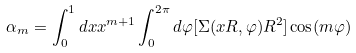<formula> <loc_0><loc_0><loc_500><loc_500>\alpha _ { m } = \int _ { 0 } ^ { 1 } { d x x ^ { m + 1 } \int _ { 0 } ^ { 2 \pi } { d \varphi [ \Sigma ( x R , \varphi ) R ^ { 2 } ] \cos ( m \varphi ) } }</formula> 